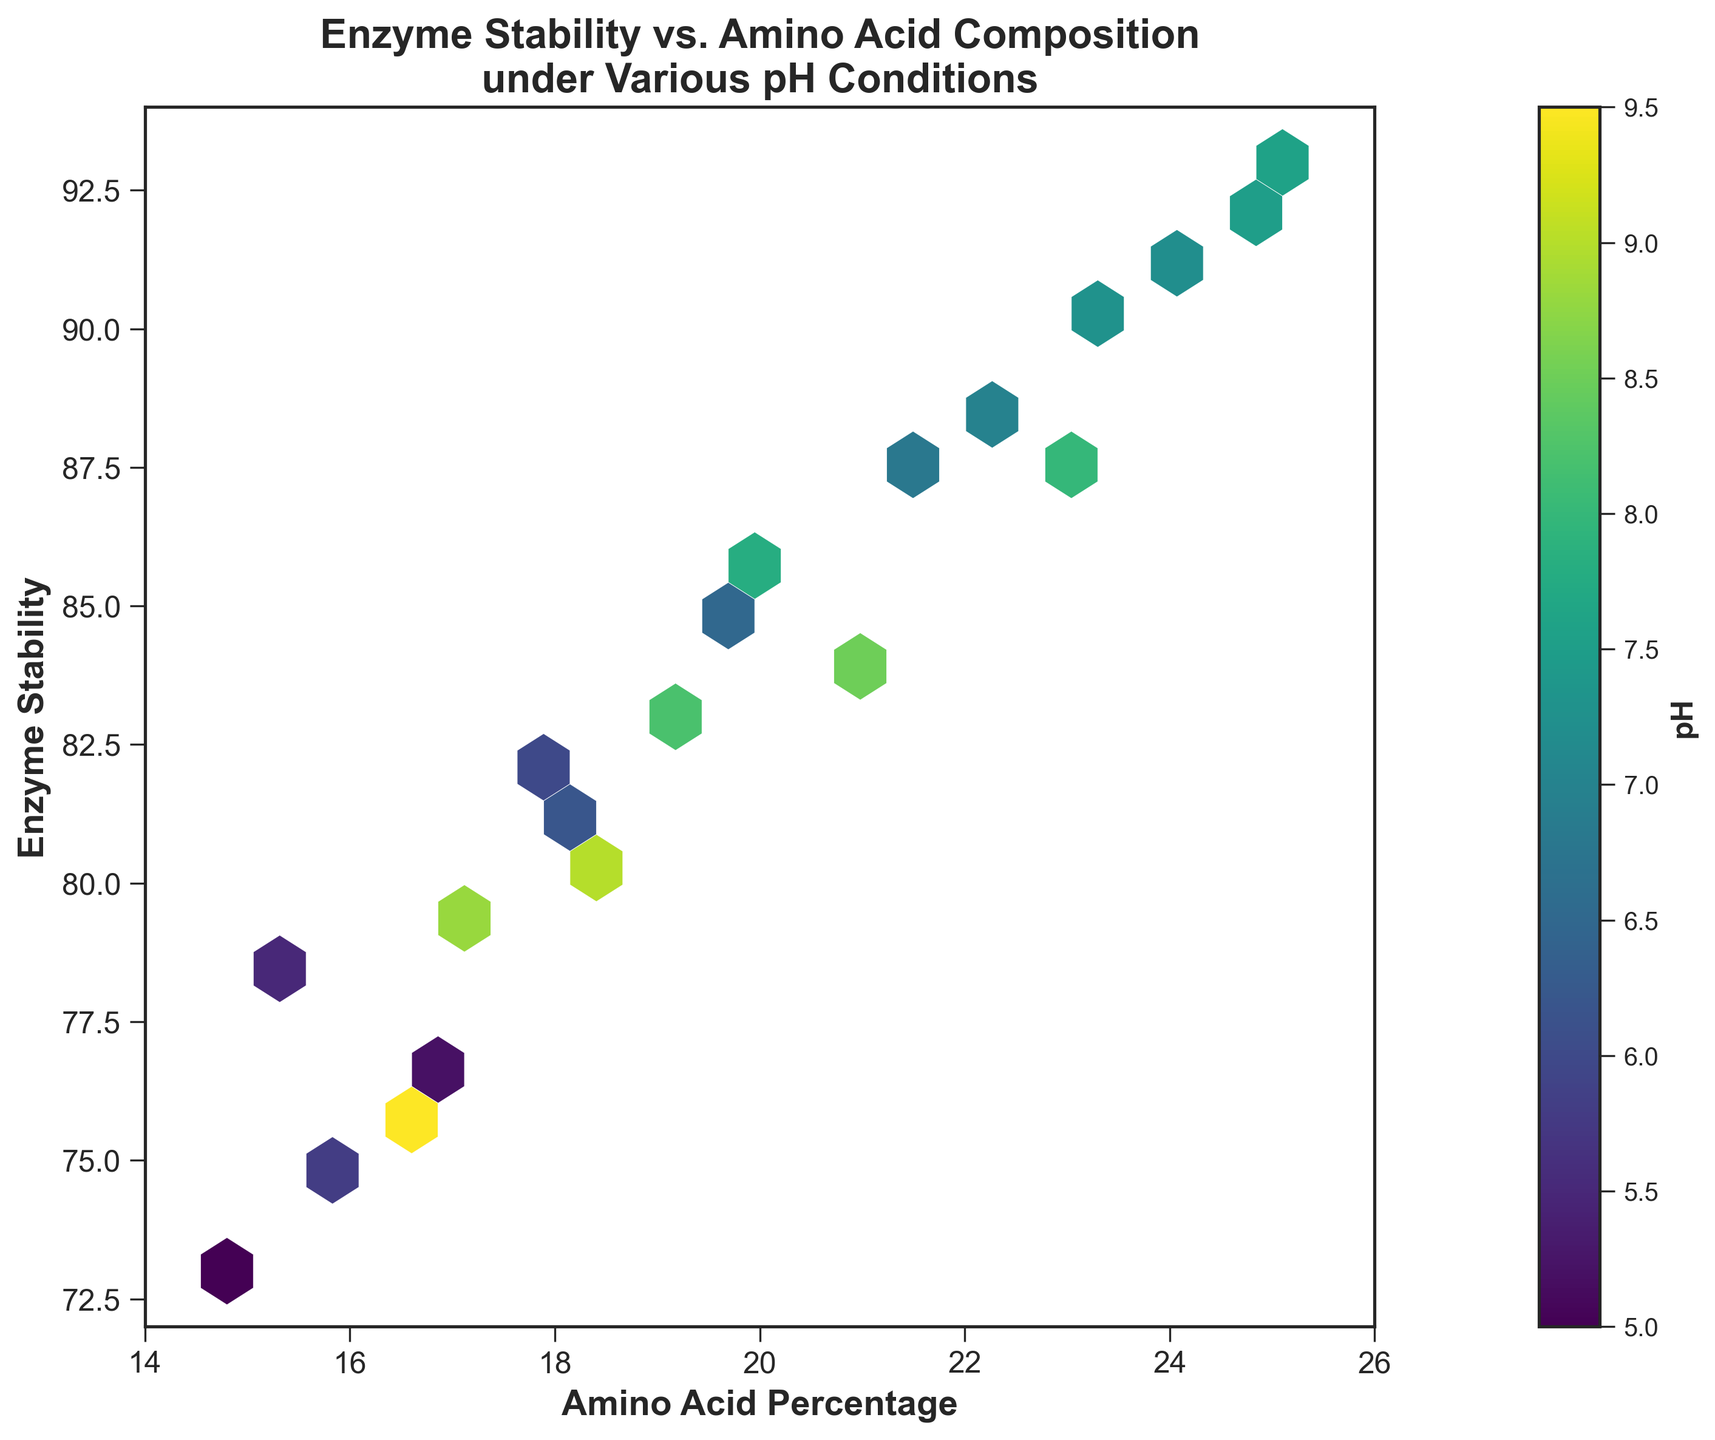What's the title of the hexbin plot? The title is displayed at the top center of the plot.
Answer: Enzyme Stability vs. Amino Acid Composition under Various pH Conditions What are the labels of the x and y axes? The x-axis label is at the bottom of the horizontal axis and the y-axis label is on the side of the vertical axis.
Answer: Amino Acid Percentage, Enzyme Stability What color represents the lowest pH values in the hexbin plot? The color bar on the right indicates that the lowest pH values are represented by the darkest colors at the bottom of the color spectrum.
Answer: Dark Blue What is the range of amino acid percentages displayed on the x-axis? The x-axis shows the range of values for amino acid percentage from the minimum to maximum value displayed on the axis.
Answer: 14 to 26 What is the range of enzyme stability displayed on the y-axis? The y-axis shows the range of values for enzyme stability from the minimum to maximum value displayed on the axis.
Answer: 72 to 94 How does the enzyme stability correlate with the amino acid percentage in the plot? By examining the plot, we can observe whether there's a trend showing stability increasing or decreasing with amino acid percentage.
Answer: Positive Correlation Does higher amino acid percentage generally correspond to a higher or lower pH value? Observing the color gradient in the plot with respect to higher amino acid percentages helps determine this relationship.
Answer: Higher pH Which amino acid percentage range shows the highest density of data points? By looking for the hexagon clusters with the highest concentration, we can determine where data points are densest.
Answer: 20.0 to 25.0 Which enzyme stability range shows the highest density of data points? Similar to the previous question, here we look at the y-axis range where hexagon clusters are densest, indicating higher data concentration.
Answer: 85 to 92 Is there a specific pH value range that appears more frequently in the plot? Examining the color distribution across hexagons can provide insights into the most frequent pH values.
Answer: 7.0 to 8.0 